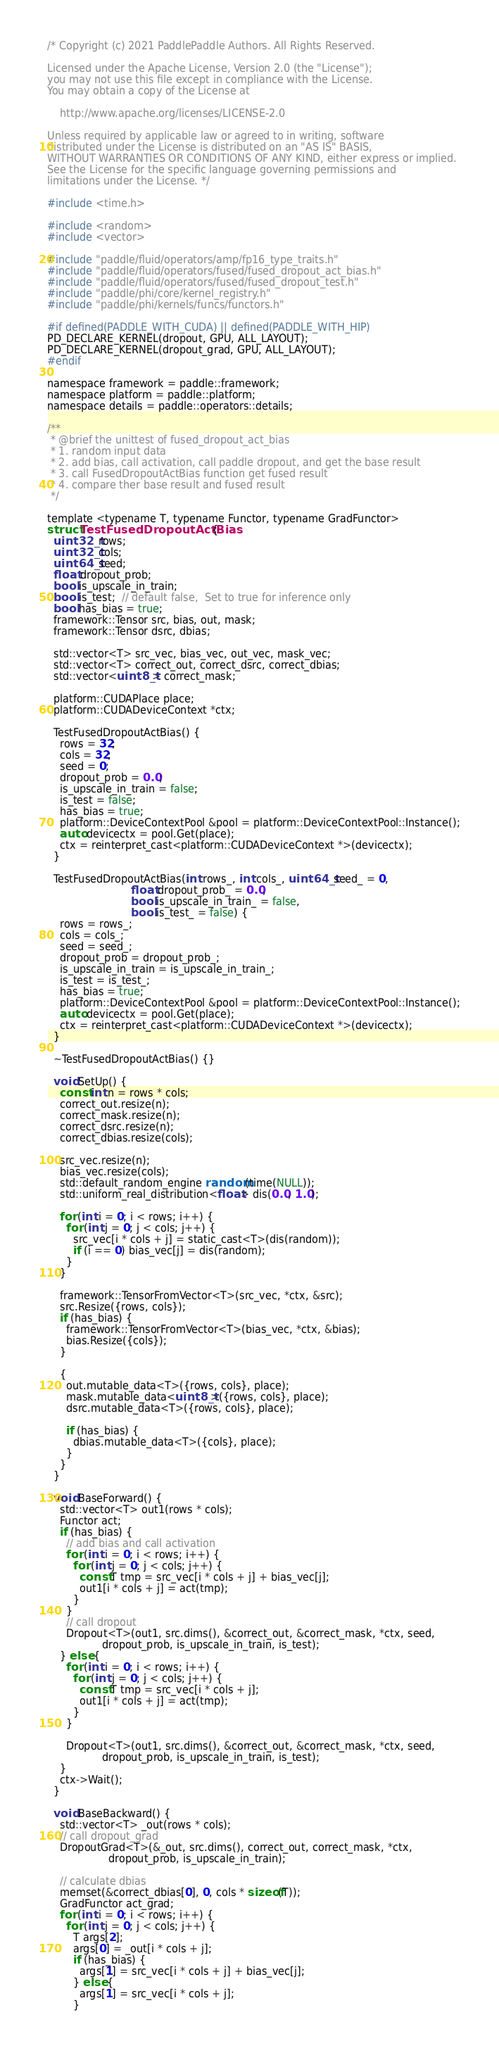<code> <loc_0><loc_0><loc_500><loc_500><_Cuda_>/* Copyright (c) 2021 PaddlePaddle Authors. All Rights Reserved.

Licensed under the Apache License, Version 2.0 (the "License");
you may not use this file except in compliance with the License.
You may obtain a copy of the License at

    http://www.apache.org/licenses/LICENSE-2.0

Unless required by applicable law or agreed to in writing, software
distributed under the License is distributed on an "AS IS" BASIS,
WITHOUT WARRANTIES OR CONDITIONS OF ANY KIND, either express or implied.
See the License for the specific language governing permissions and
limitations under the License. */

#include <time.h>

#include <random>
#include <vector>

#include "paddle/fluid/operators/amp/fp16_type_traits.h"
#include "paddle/fluid/operators/fused/fused_dropout_act_bias.h"
#include "paddle/fluid/operators/fused/fused_dropout_test.h"
#include "paddle/phi/core/kernel_registry.h"
#include "paddle/phi/kernels/funcs/functors.h"

#if defined(PADDLE_WITH_CUDA) || defined(PADDLE_WITH_HIP)
PD_DECLARE_KERNEL(dropout, GPU, ALL_LAYOUT);
PD_DECLARE_KERNEL(dropout_grad, GPU, ALL_LAYOUT);
#endif

namespace framework = paddle::framework;
namespace platform = paddle::platform;
namespace details = paddle::operators::details;

/**
 * @brief the unittest of fused_dropout_act_bias
 * 1. random input data
 * 2. add bias, call activation, call paddle dropout, and get the base result
 * 3. call FusedDropoutActBias function get fused result
 * 4. compare ther base result and fused result
 */

template <typename T, typename Functor, typename GradFunctor>
struct TestFusedDropoutActBias {
  uint32_t rows;
  uint32_t cols;
  uint64_t seed;
  float dropout_prob;
  bool is_upscale_in_train;
  bool is_test;  // default false,  Set to true for inference only
  bool has_bias = true;
  framework::Tensor src, bias, out, mask;
  framework::Tensor dsrc, dbias;

  std::vector<T> src_vec, bias_vec, out_vec, mask_vec;
  std::vector<T> correct_out, correct_dsrc, correct_dbias;
  std::vector<uint8_t> correct_mask;

  platform::CUDAPlace place;
  platform::CUDADeviceContext *ctx;

  TestFusedDropoutActBias() {
    rows = 32;
    cols = 32;
    seed = 0;
    dropout_prob = 0.0;
    is_upscale_in_train = false;
    is_test = false;
    has_bias = true;
    platform::DeviceContextPool &pool = platform::DeviceContextPool::Instance();
    auto devicectx = pool.Get(place);
    ctx = reinterpret_cast<platform::CUDADeviceContext *>(devicectx);
  }

  TestFusedDropoutActBias(int rows_, int cols_, uint64_t seed_ = 0,
                          float dropout_prob_ = 0.0,
                          bool is_upscale_in_train_ = false,
                          bool is_test_ = false) {
    rows = rows_;
    cols = cols_;
    seed = seed_;
    dropout_prob = dropout_prob_;
    is_upscale_in_train = is_upscale_in_train_;
    is_test = is_test_;
    has_bias = true;
    platform::DeviceContextPool &pool = platform::DeviceContextPool::Instance();
    auto devicectx = pool.Get(place);
    ctx = reinterpret_cast<platform::CUDADeviceContext *>(devicectx);
  }

  ~TestFusedDropoutActBias() {}

  void SetUp() {
    const int n = rows * cols;
    correct_out.resize(n);
    correct_mask.resize(n);
    correct_dsrc.resize(n);
    correct_dbias.resize(cols);

    src_vec.resize(n);
    bias_vec.resize(cols);
    std::default_random_engine random(time(NULL));
    std::uniform_real_distribution<float> dis(0.0, 1.0);

    for (int i = 0; i < rows; i++) {
      for (int j = 0; j < cols; j++) {
        src_vec[i * cols + j] = static_cast<T>(dis(random));
        if (i == 0) bias_vec[j] = dis(random);
      }
    }

    framework::TensorFromVector<T>(src_vec, *ctx, &src);
    src.Resize({rows, cols});
    if (has_bias) {
      framework::TensorFromVector<T>(bias_vec, *ctx, &bias);
      bias.Resize({cols});
    }

    {
      out.mutable_data<T>({rows, cols}, place);
      mask.mutable_data<uint8_t>({rows, cols}, place);
      dsrc.mutable_data<T>({rows, cols}, place);

      if (has_bias) {
        dbias.mutable_data<T>({cols}, place);
      }
    }
  }

  void BaseForward() {
    std::vector<T> out1(rows * cols);
    Functor act;
    if (has_bias) {
      // add bias and call activation
      for (int i = 0; i < rows; i++) {
        for (int j = 0; j < cols; j++) {
          const T tmp = src_vec[i * cols + j] + bias_vec[j];
          out1[i * cols + j] = act(tmp);
        }
      }
      // call dropout
      Dropout<T>(out1, src.dims(), &correct_out, &correct_mask, *ctx, seed,
                 dropout_prob, is_upscale_in_train, is_test);
    } else {
      for (int i = 0; i < rows; i++) {
        for (int j = 0; j < cols; j++) {
          const T tmp = src_vec[i * cols + j];
          out1[i * cols + j] = act(tmp);
        }
      }

      Dropout<T>(out1, src.dims(), &correct_out, &correct_mask, *ctx, seed,
                 dropout_prob, is_upscale_in_train, is_test);
    }
    ctx->Wait();
  }

  void BaseBackward() {
    std::vector<T> _out(rows * cols);
    // call dropout_grad
    DropoutGrad<T>(&_out, src.dims(), correct_out, correct_mask, *ctx,
                   dropout_prob, is_upscale_in_train);

    // calculate dbias
    memset(&correct_dbias[0], 0, cols * sizeof(T));
    GradFunctor act_grad;
    for (int i = 0; i < rows; i++) {
      for (int j = 0; j < cols; j++) {
        T args[2];
        args[0] = _out[i * cols + j];
        if (has_bias) {
          args[1] = src_vec[i * cols + j] + bias_vec[j];
        } else {
          args[1] = src_vec[i * cols + j];
        }</code> 